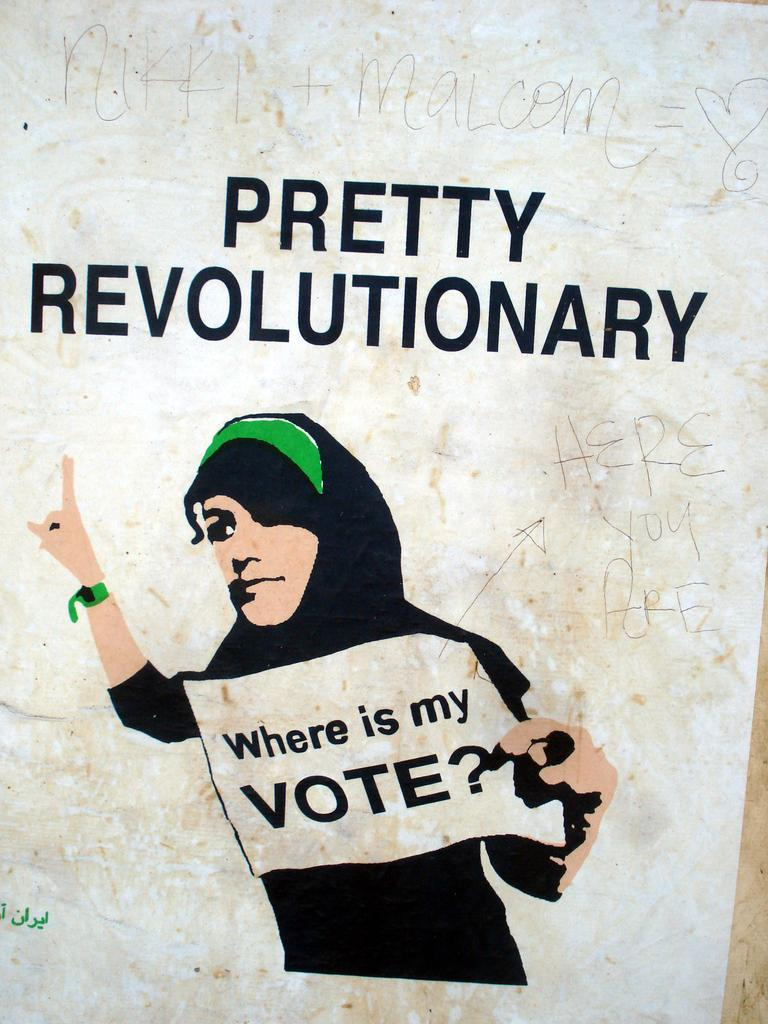What is the main subject of the image? There is a depiction of a woman in the image. What is the woman holding in her hand? The woman is holding a paper in her hand. What can be found on the paper? There is text on the paper. Can you describe the text at the top of the image? There is text written at the top of the image. How is the text at the top of the image presented? There is text printed at the top of the image. What type of clouds can be seen in the image? There are no clouds present in the image; it features a depiction of a woman holding a paper with text. 